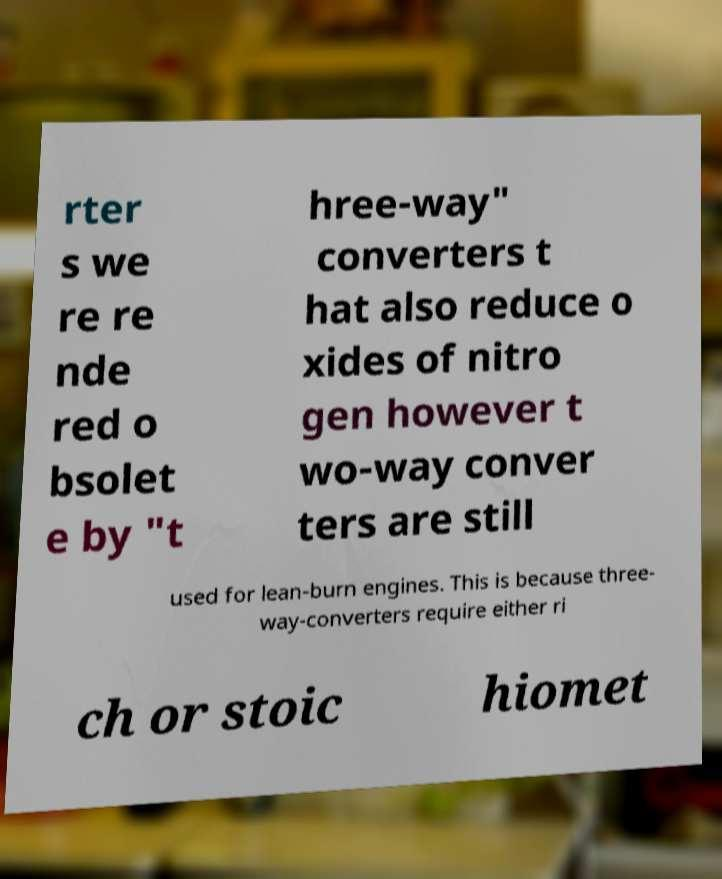Please identify and transcribe the text found in this image. rter s we re re nde red o bsolet e by "t hree-way" converters t hat also reduce o xides of nitro gen however t wo-way conver ters are still used for lean-burn engines. This is because three- way-converters require either ri ch or stoic hiomet 